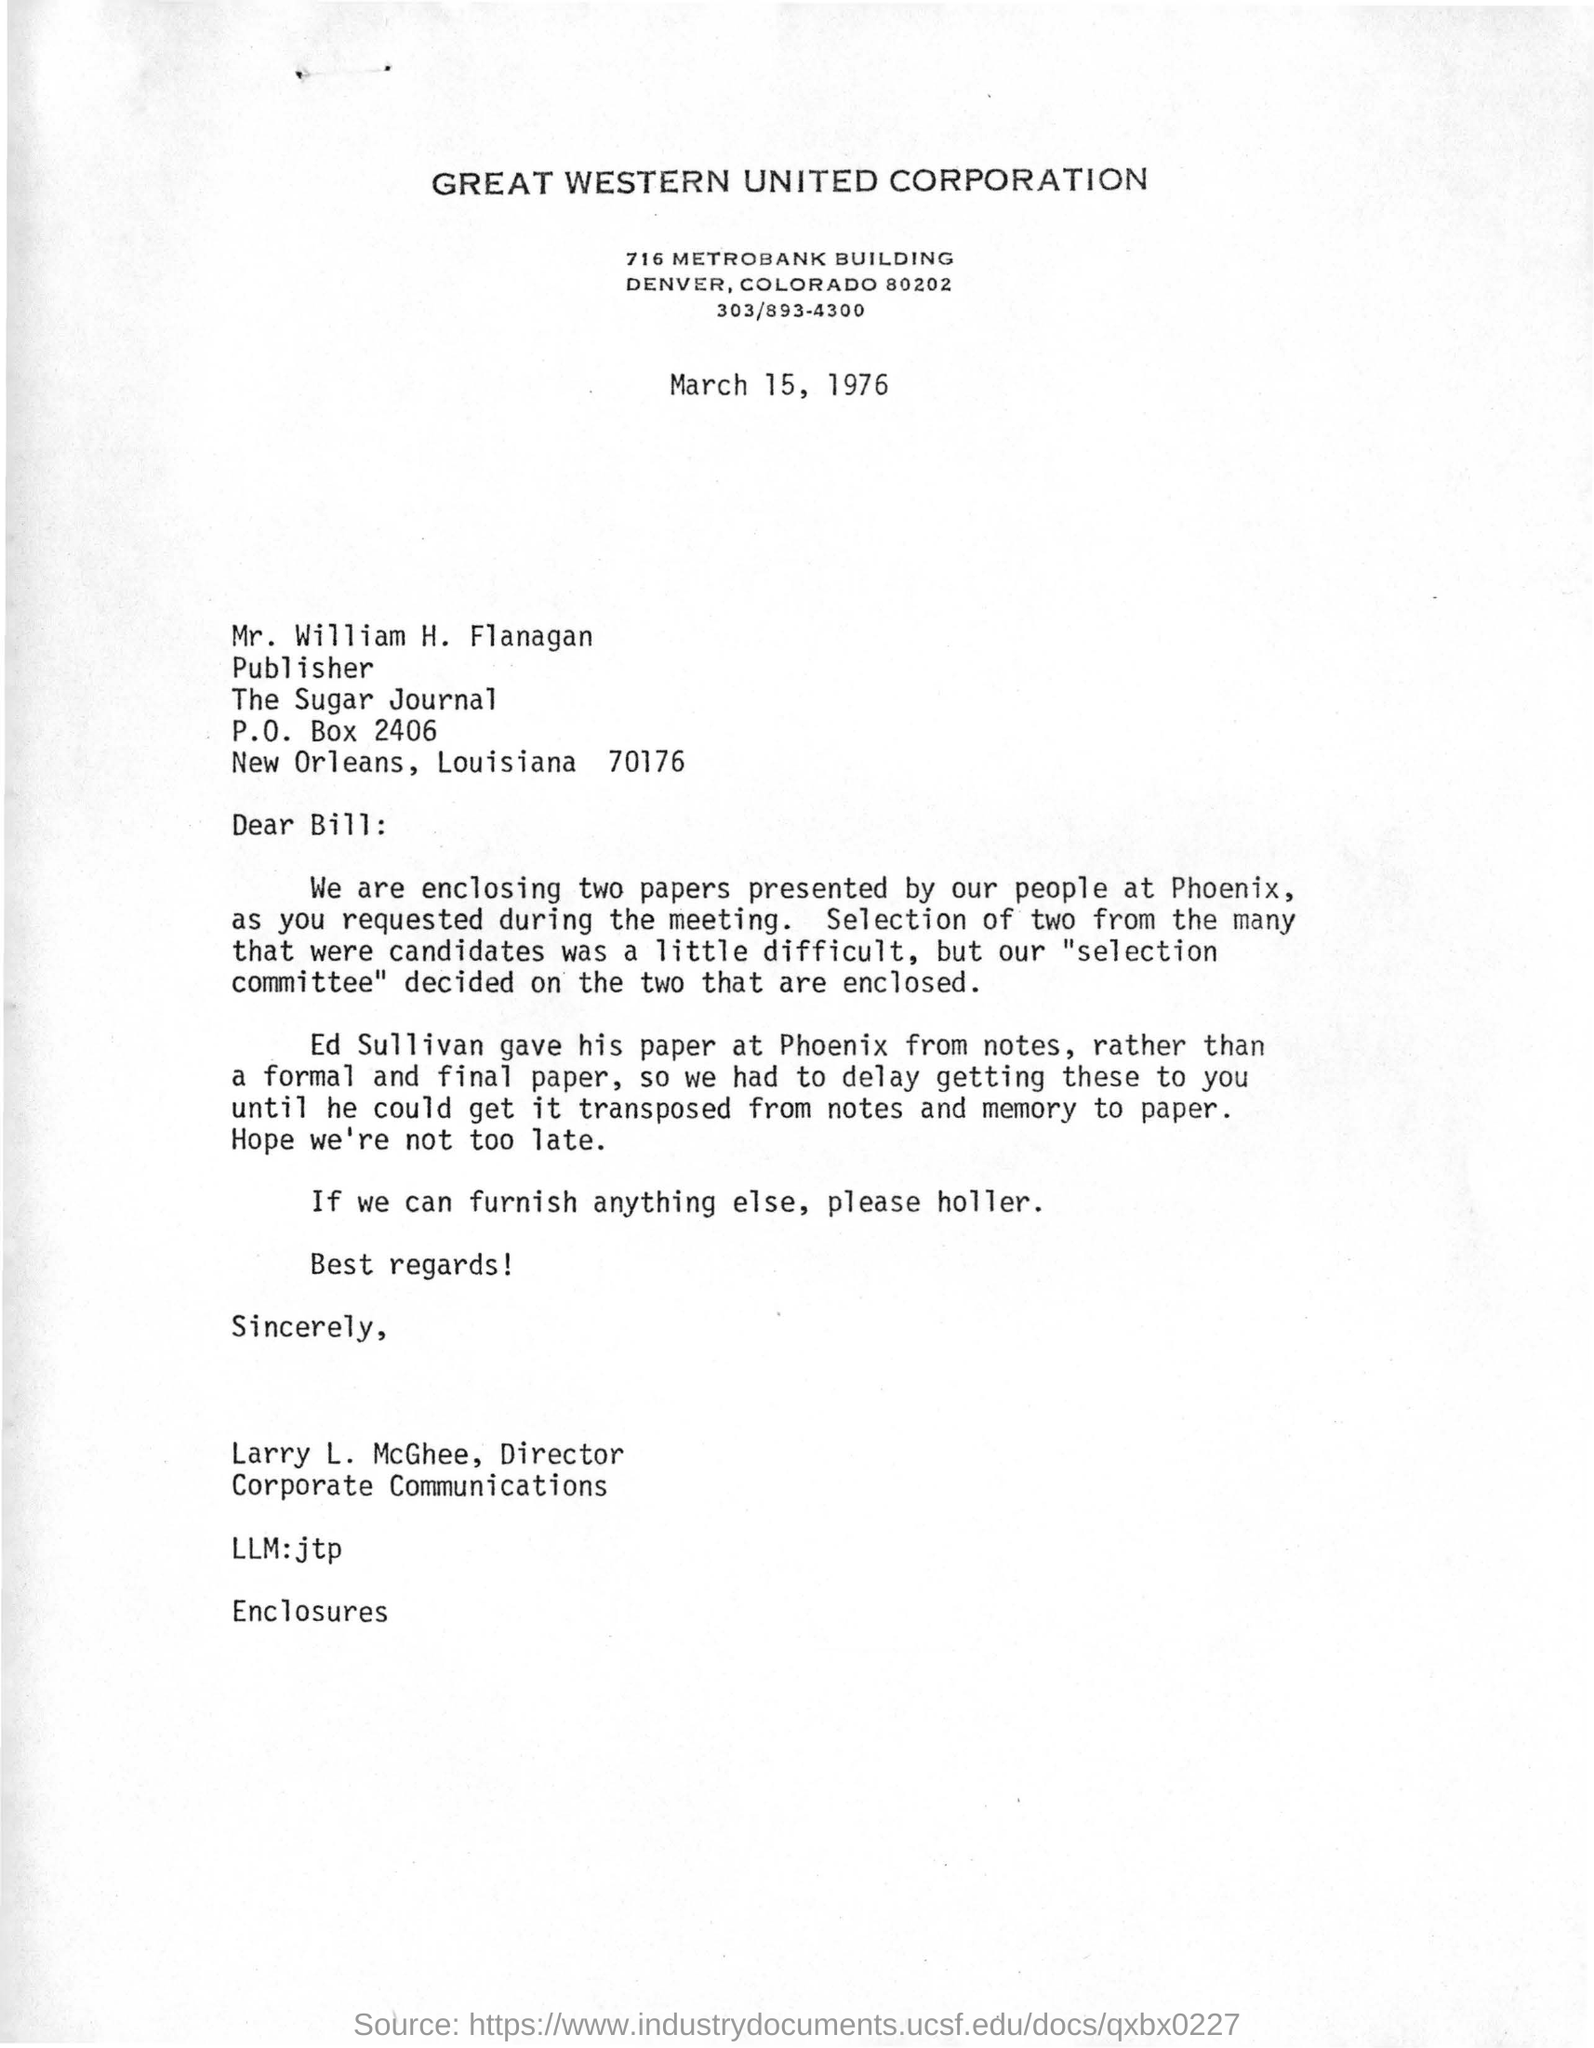When is this letter dated?
Make the answer very short. March 15, 1976. What is the kind of corporation mentioned in the letter?
Offer a very short reply. Great western united corporation. Who is the director for corporate communications?
Your answer should be very brief. Larry L. McGhee,. Who is the publisher for the sugar journal?
Keep it short and to the point. Mr. William H. Flanagan. 